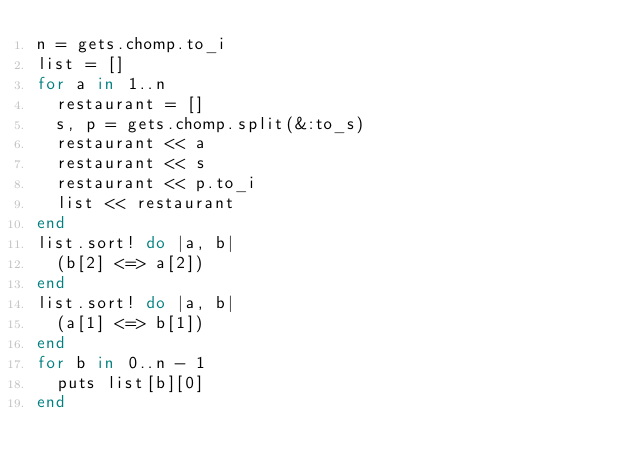<code> <loc_0><loc_0><loc_500><loc_500><_Ruby_>n = gets.chomp.to_i
list = []
for a in 1..n
  restaurant = []
  s, p = gets.chomp.split(&:to_s)
  restaurant << a
  restaurant << s
  restaurant << p.to_i
  list << restaurant
end
list.sort! do |a, b|
  (b[2] <=> a[2])
end
list.sort! do |a, b|
  (a[1] <=> b[1])
end
for b in 0..n - 1
  puts list[b][0]
end
</code> 